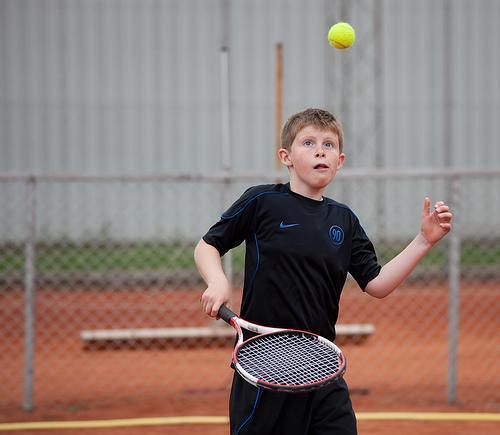How many players?
Give a very brief answer. 1. 